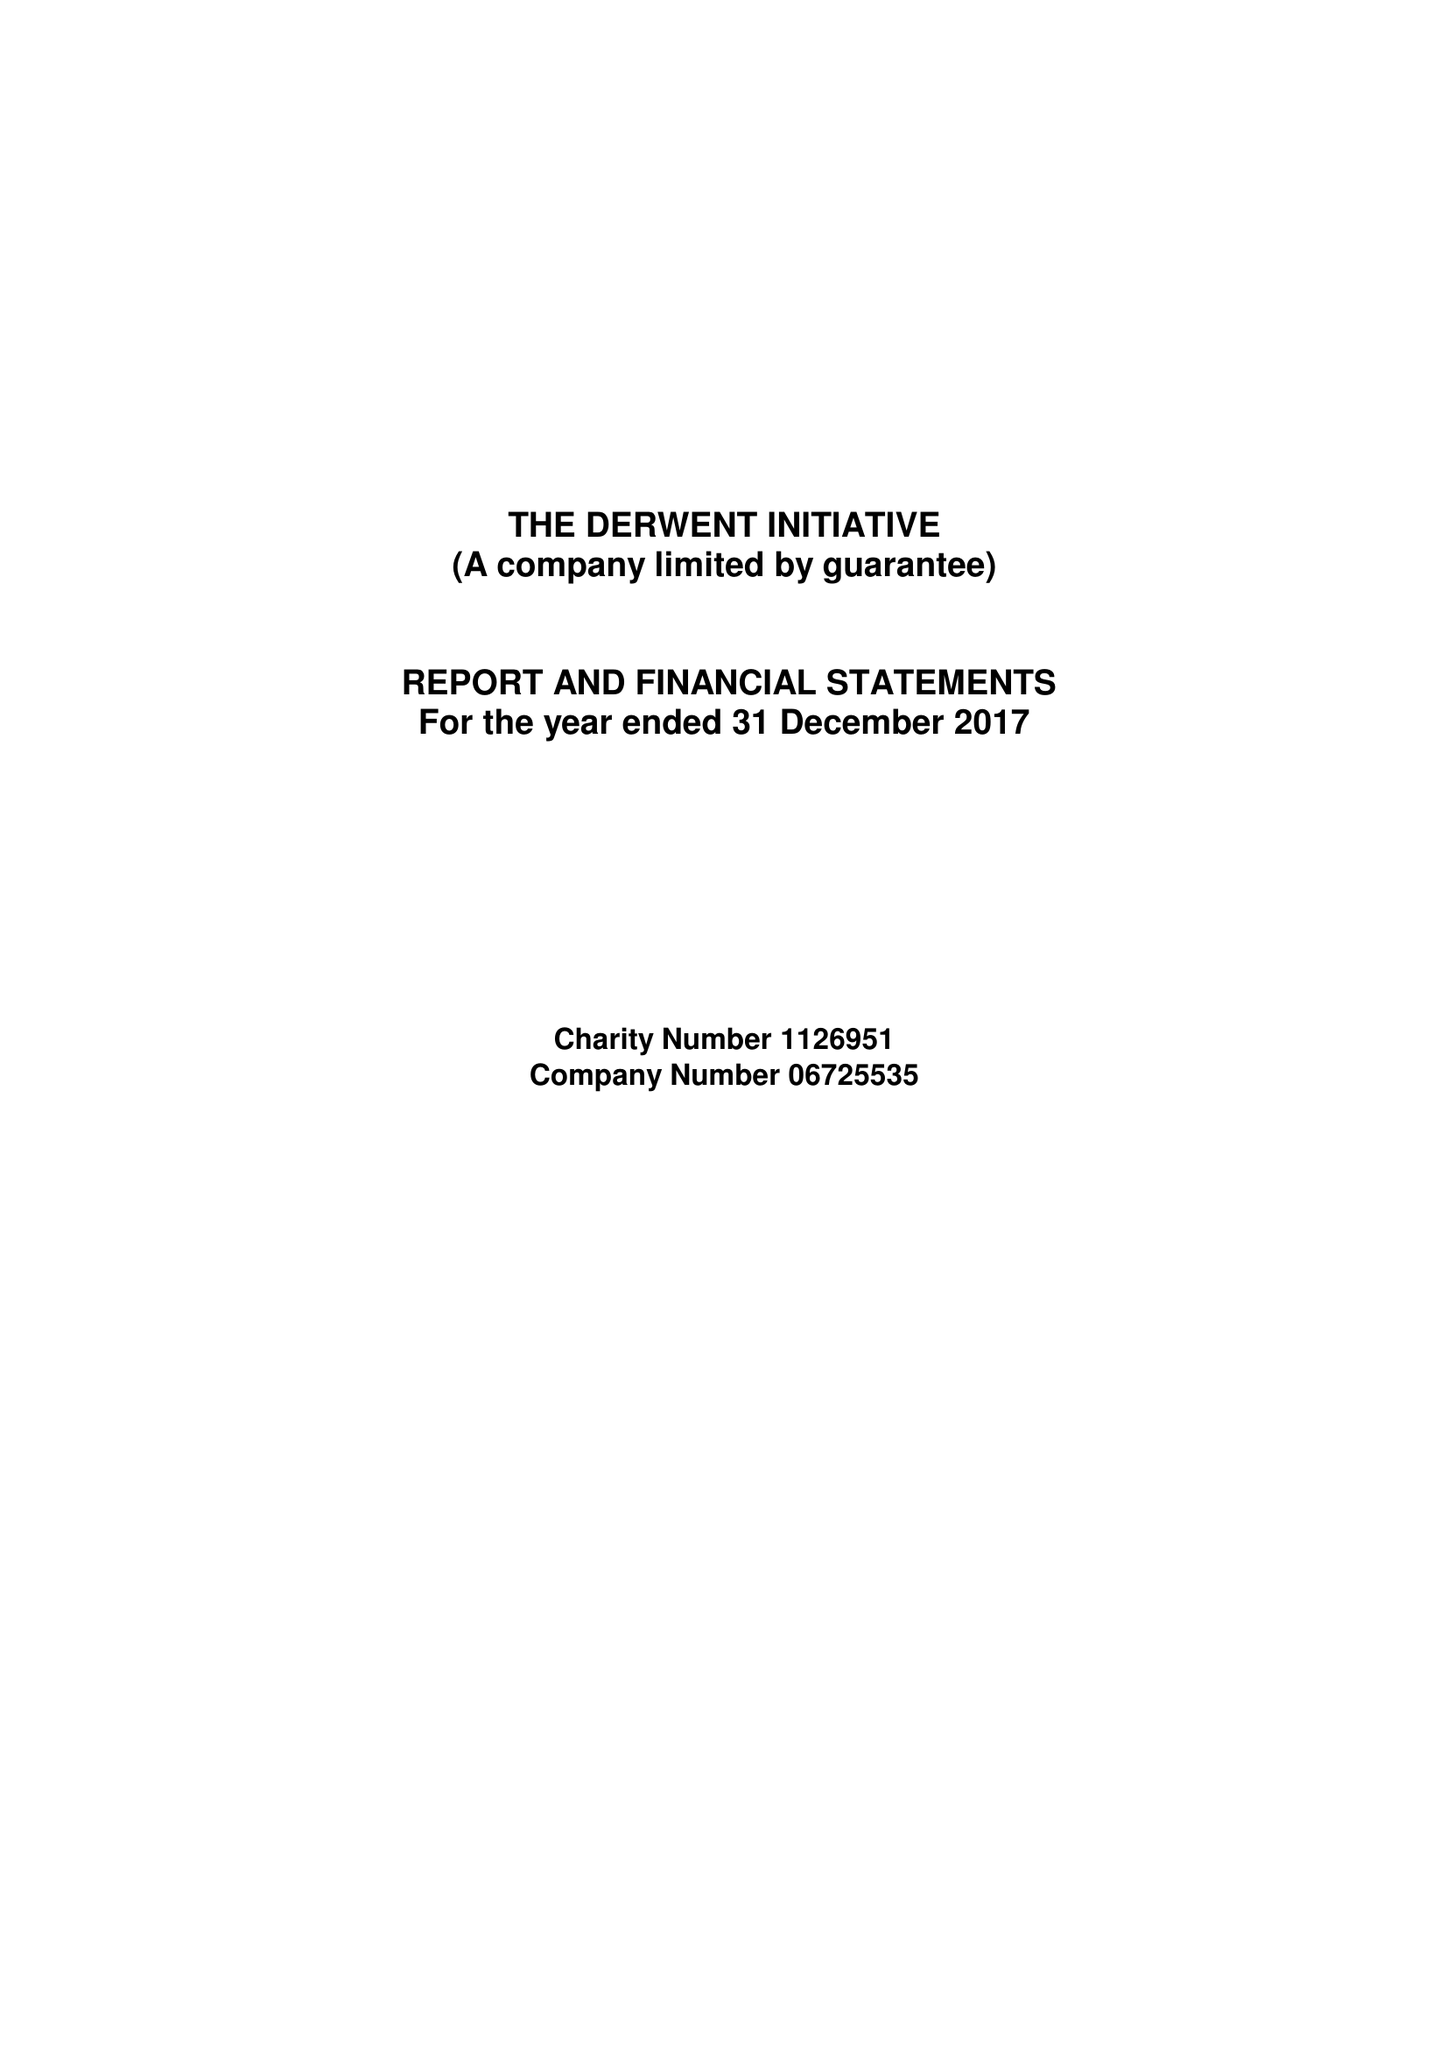What is the value for the income_annually_in_british_pounds?
Answer the question using a single word or phrase. 86306.00 